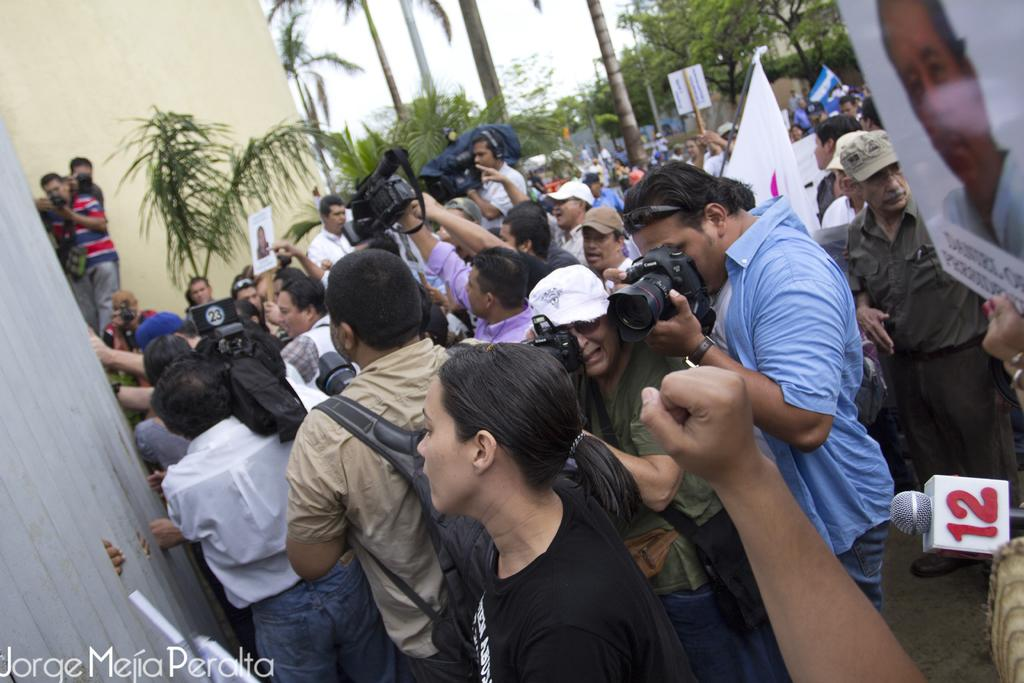What can be seen in the image involving people? There are people standing in the image. What objects are present in the image that are related to photography? There are cameras in the image. What type of natural elements can be seen in the image? There are trees and plants in the image. What type of structure is visible in the image? There is a wall in the image. How many children are playing with the rod in the image? There is no rod or children present in the image. What type of tools might a carpenter use in the image? There is no carpenter or tools present in the image. 